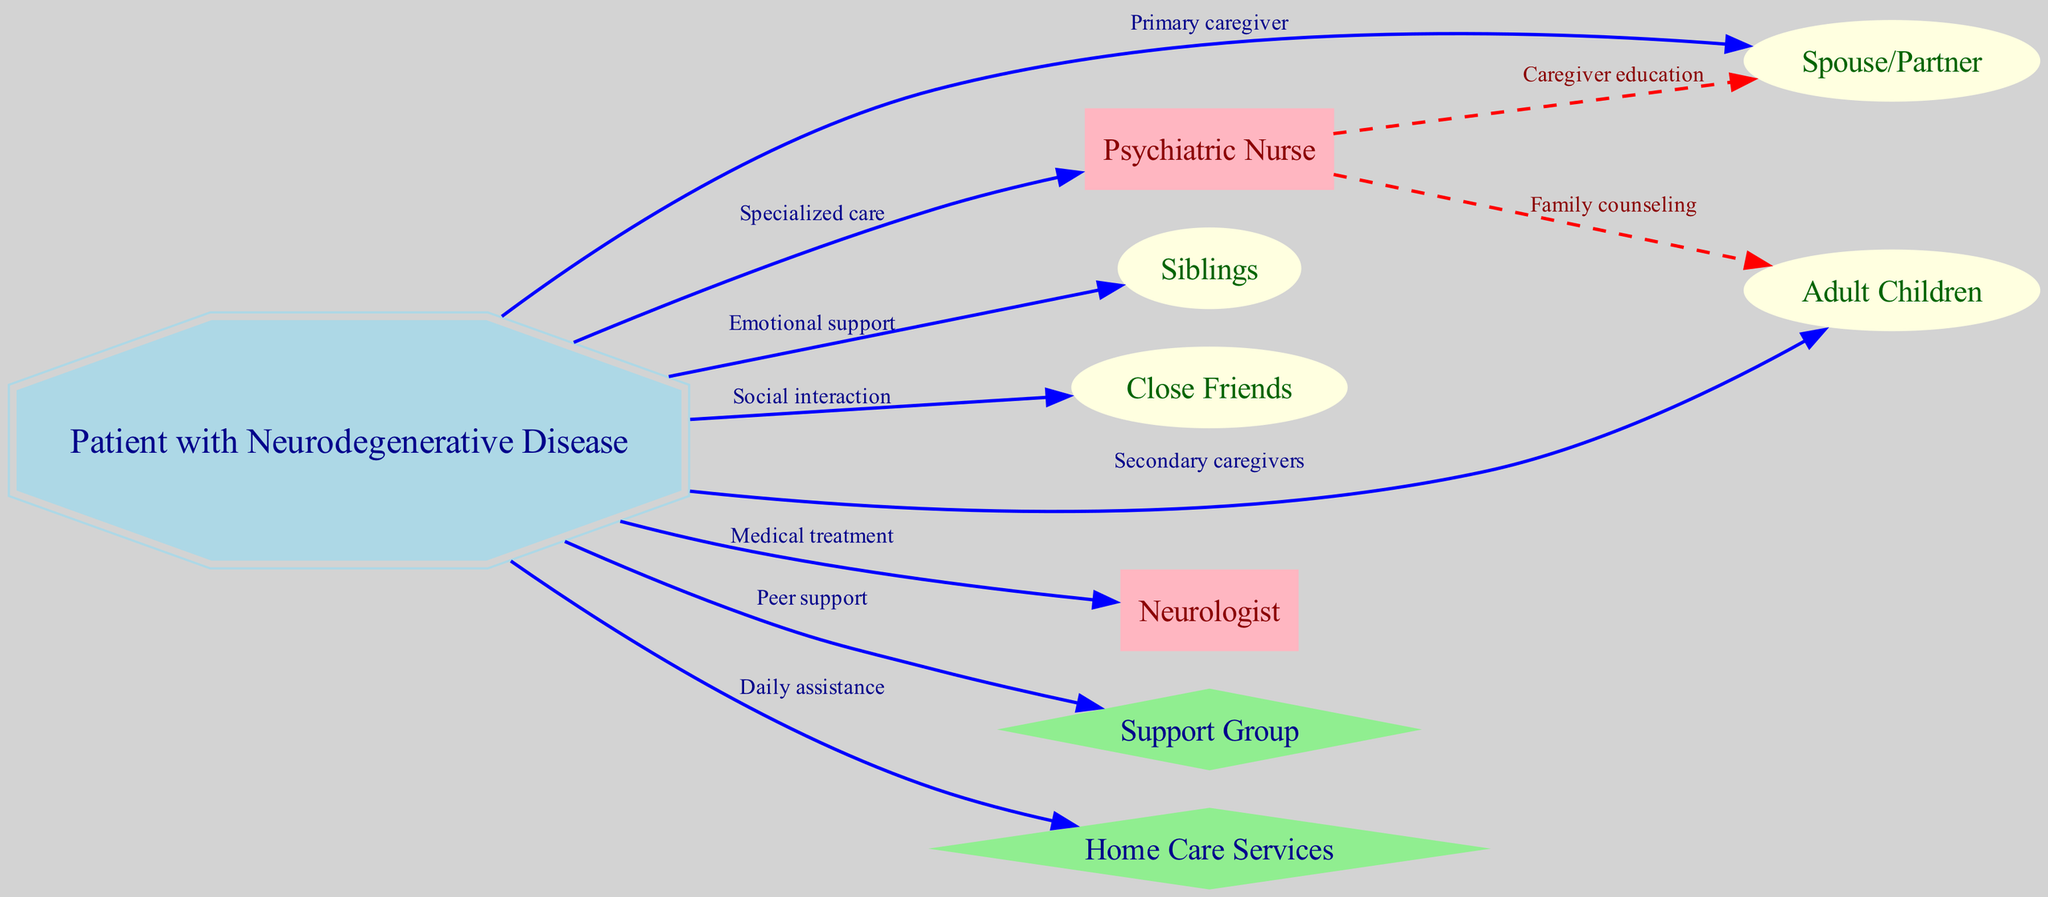What is the primary caregiver in this diagram? The diagram indicates that the primary caregiver is the spouse/partner, as there is a direct edge labeled "Primary caregiver" from the patient to the spouse.
Answer: Spouse/Partner How many nodes are present in the diagram? To determine the number of nodes, we can count each unique entity listed. The diagram has nine nodes: one for the patient, one for the spouse, adult children, siblings, friends, nurse, neurologist, support group, and home care services.
Answer: 9 What relationship connects the patient to the neurologist? The relationship between the patient and the neurologist is indicated by the edge labeled "Medical treatment", showing that the neurologist provides medical care to the patient.
Answer: Medical treatment What type of relationship do siblings provide to the patient? The siblings are connected to the patient via an edge labeled "Emotional support," indicating their role in providing emotional assistance.
Answer: Emotional support How many caregivers are listed in the diagram? By examining the connections, the caregivers include the spouse (primary), children (secondary), nurse, and home care services, totaling four caregivers specified in the diagram.
Answer: 4 What is an example of peer support in this diagram? The support group is identified as an example of peer support in this diagram, connected to the patient with the label "Peer support."
Answer: Support Group Which entity receives caregiver education from the nurse? The nurse provides caregiver education to the spouse, indicated by the edge that specifically states this relationship with the label "Caregiver education."
Answer: Spouse/Partner What kind of support do the friends offer to the patient? The friends are linked to the patient for "Social interaction," indicating their role in facilitating social engagement.
Answer: Social interaction What services are indicated for daily assistance for the patient? The home care services are identified as the entity connected for "Daily assistance," showing their role in providing practical support to the patient.
Answer: Home Care Services 